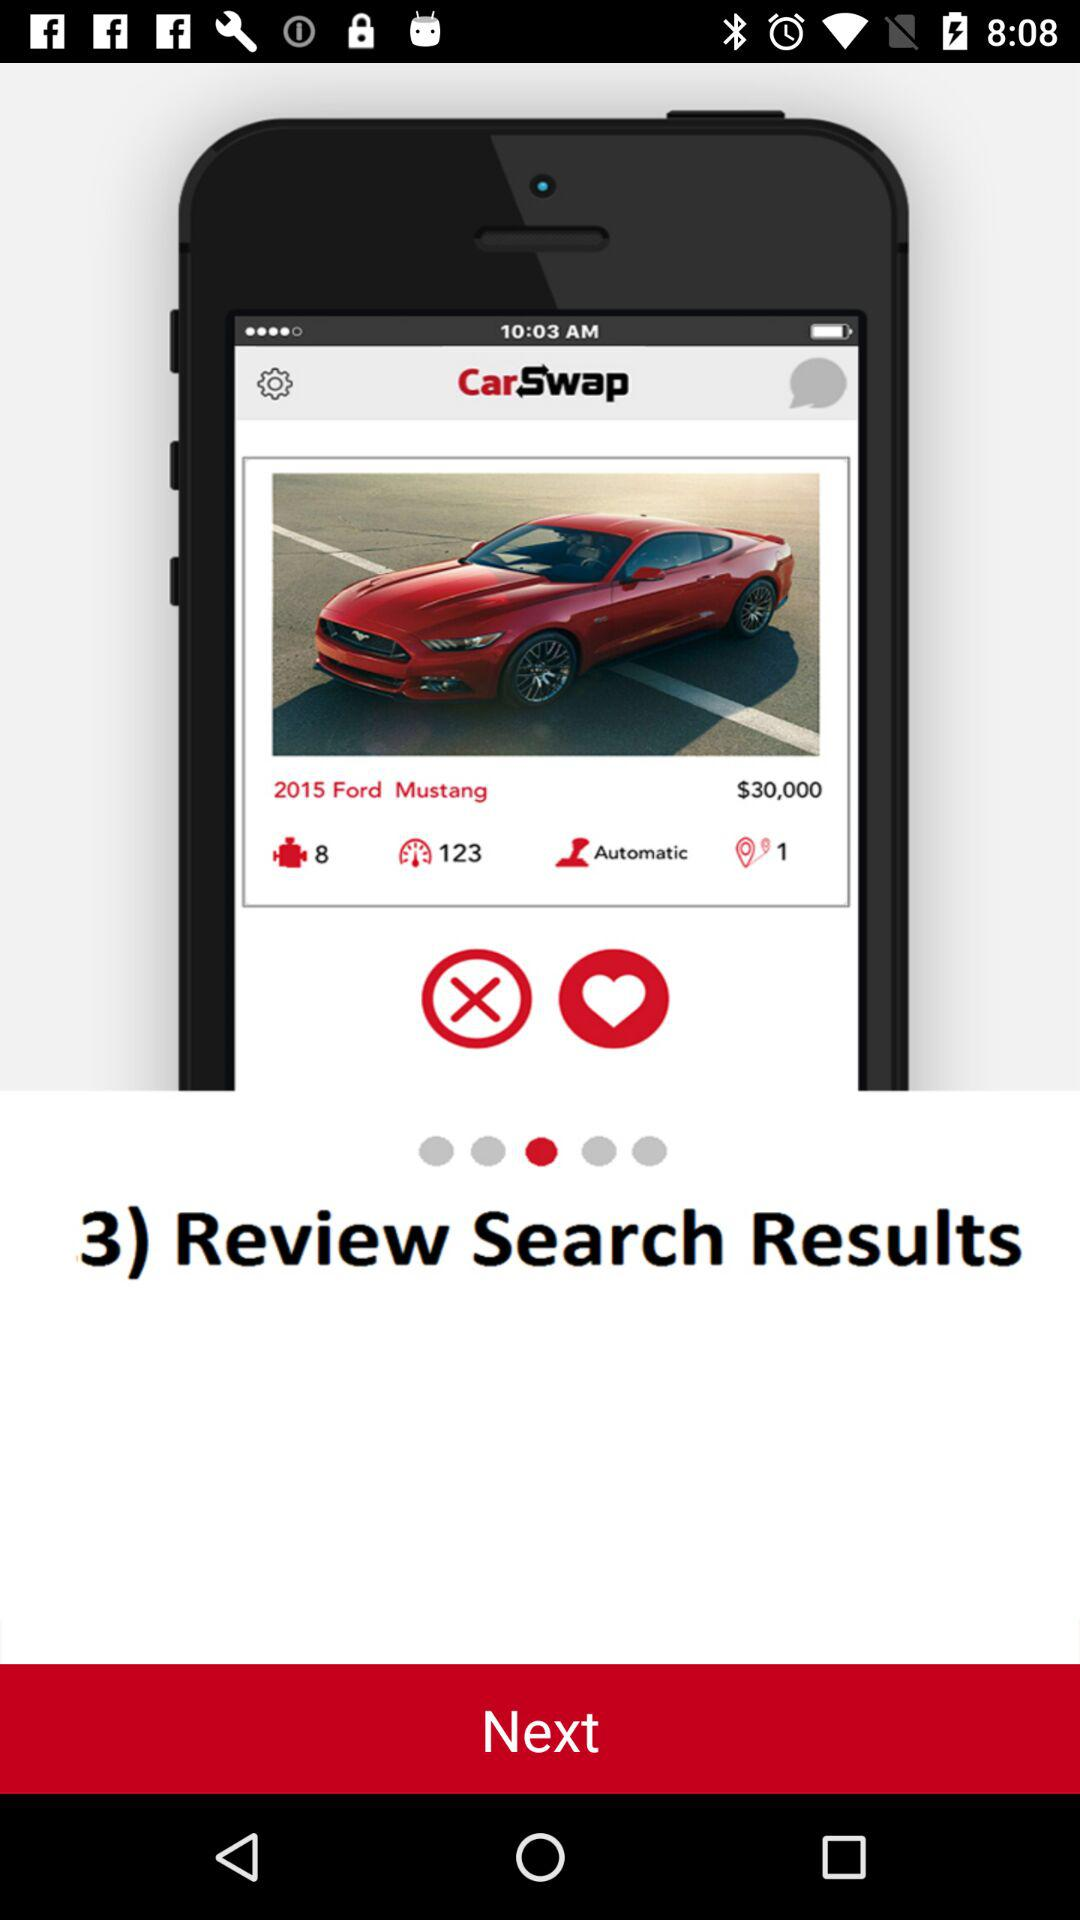How many results are shown on the screen?
Answer the question using a single word or phrase. 3 